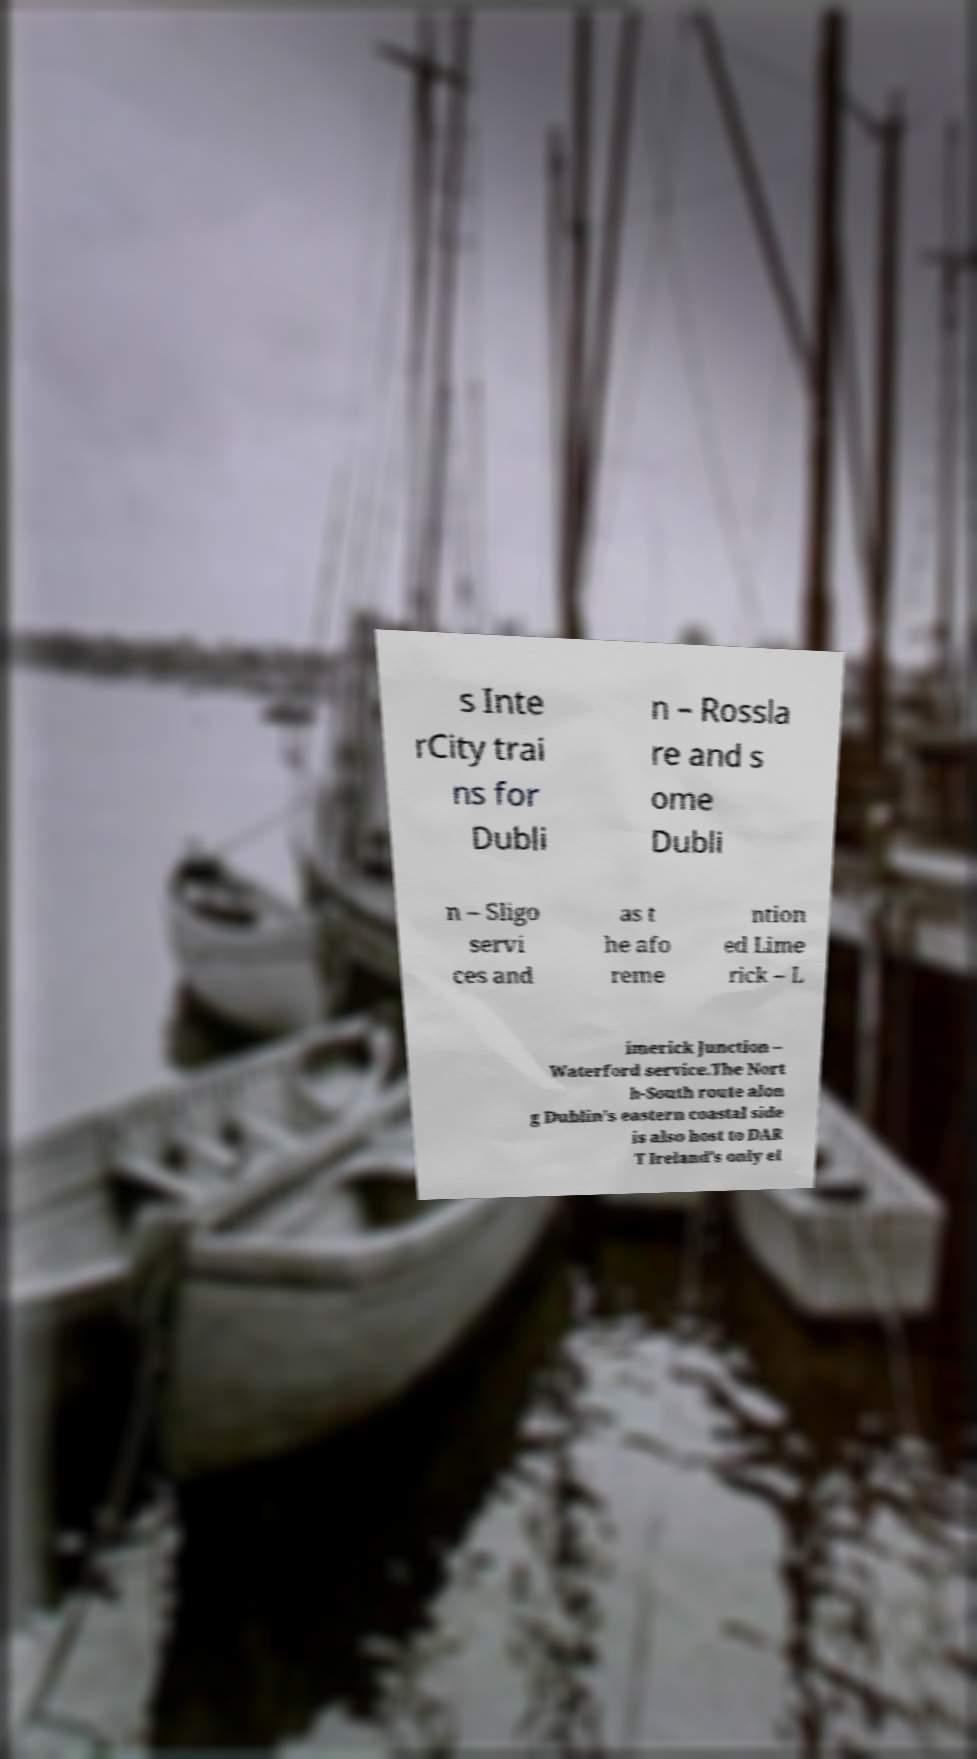Can you accurately transcribe the text from the provided image for me? s Inte rCity trai ns for Dubli n – Rossla re and s ome Dubli n – Sligo servi ces and as t he afo reme ntion ed Lime rick – L imerick Junction – Waterford service.The Nort h-South route alon g Dublin's eastern coastal side is also host to DAR T Ireland's only el 